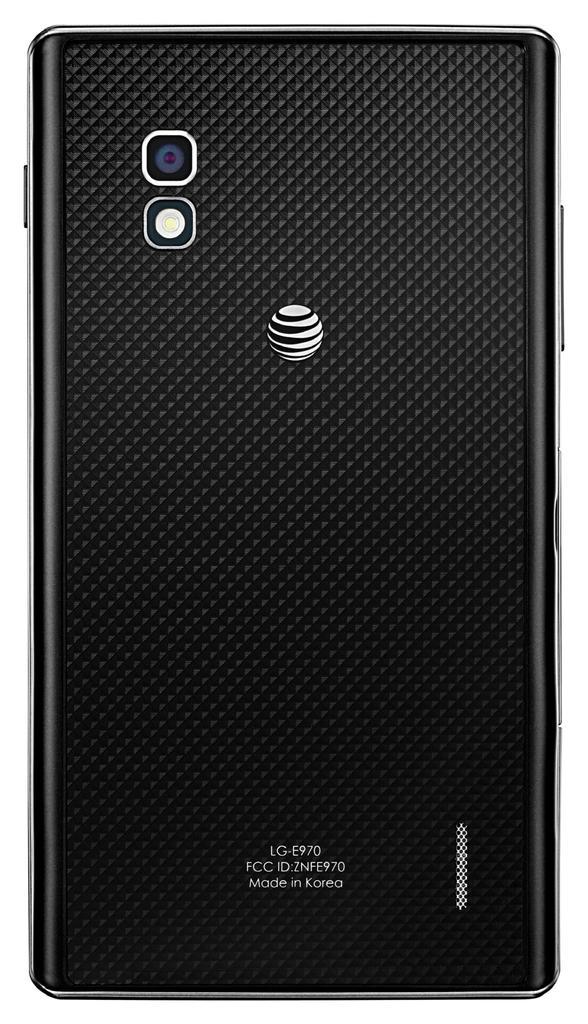In one or two sentences, can you explain what this image depicts? This is the backside view of a mobile. In this image we can see the camera lens, logo and the text on the mobile. The background of the image is white. 